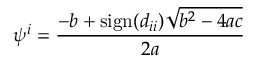Convert formula to latex. <formula><loc_0><loc_0><loc_500><loc_500>\psi ^ { i } = \frac { - b + s i g n ( d _ { i i } ) \sqrt { b ^ { 2 } - 4 a c } } { 2 a }</formula> 